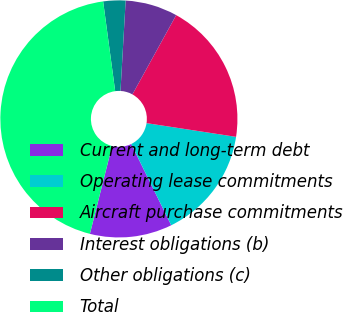Convert chart to OTSL. <chart><loc_0><loc_0><loc_500><loc_500><pie_chart><fcel>Current and long-term debt<fcel>Operating lease commitments<fcel>Aircraft purchase commitments<fcel>Interest obligations (b)<fcel>Other obligations (c)<fcel>Total<nl><fcel>11.21%<fcel>15.3%<fcel>19.39%<fcel>7.12%<fcel>3.03%<fcel>43.94%<nl></chart> 